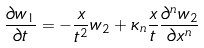<formula> <loc_0><loc_0><loc_500><loc_500>\frac { \partial w _ { 1 } } { \partial t } = - \frac { x } { t ^ { 2 } } w _ { 2 } + \kappa _ { n } \frac { x } { t } \frac { \partial ^ { n } w _ { 2 } } { \partial x ^ { n } }</formula> 